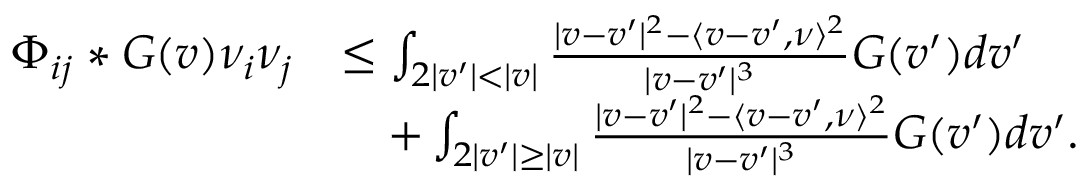Convert formula to latex. <formula><loc_0><loc_0><loc_500><loc_500>\begin{array} { r l } { \Phi _ { i j } * G ( v ) \nu _ { i } \nu _ { j } } & { \leq \int _ { 2 | v ^ { \prime } | < | v | } \frac { | v - v ^ { \prime } | ^ { 2 } - \langle v - v ^ { \prime } , \nu \rangle ^ { 2 } } { | v - v ^ { \prime } | ^ { 3 } } G ( v ^ { \prime } ) d v ^ { \prime } } \\ & { \quad + \int _ { 2 | v ^ { \prime } | \geq | v | } \frac { | v - v ^ { \prime } | ^ { 2 } - \langle v - v ^ { \prime } , \nu \rangle ^ { 2 } } { | v - v ^ { \prime } | ^ { 3 } } G ( v ^ { \prime } ) d v ^ { \prime } . } \end{array}</formula> 